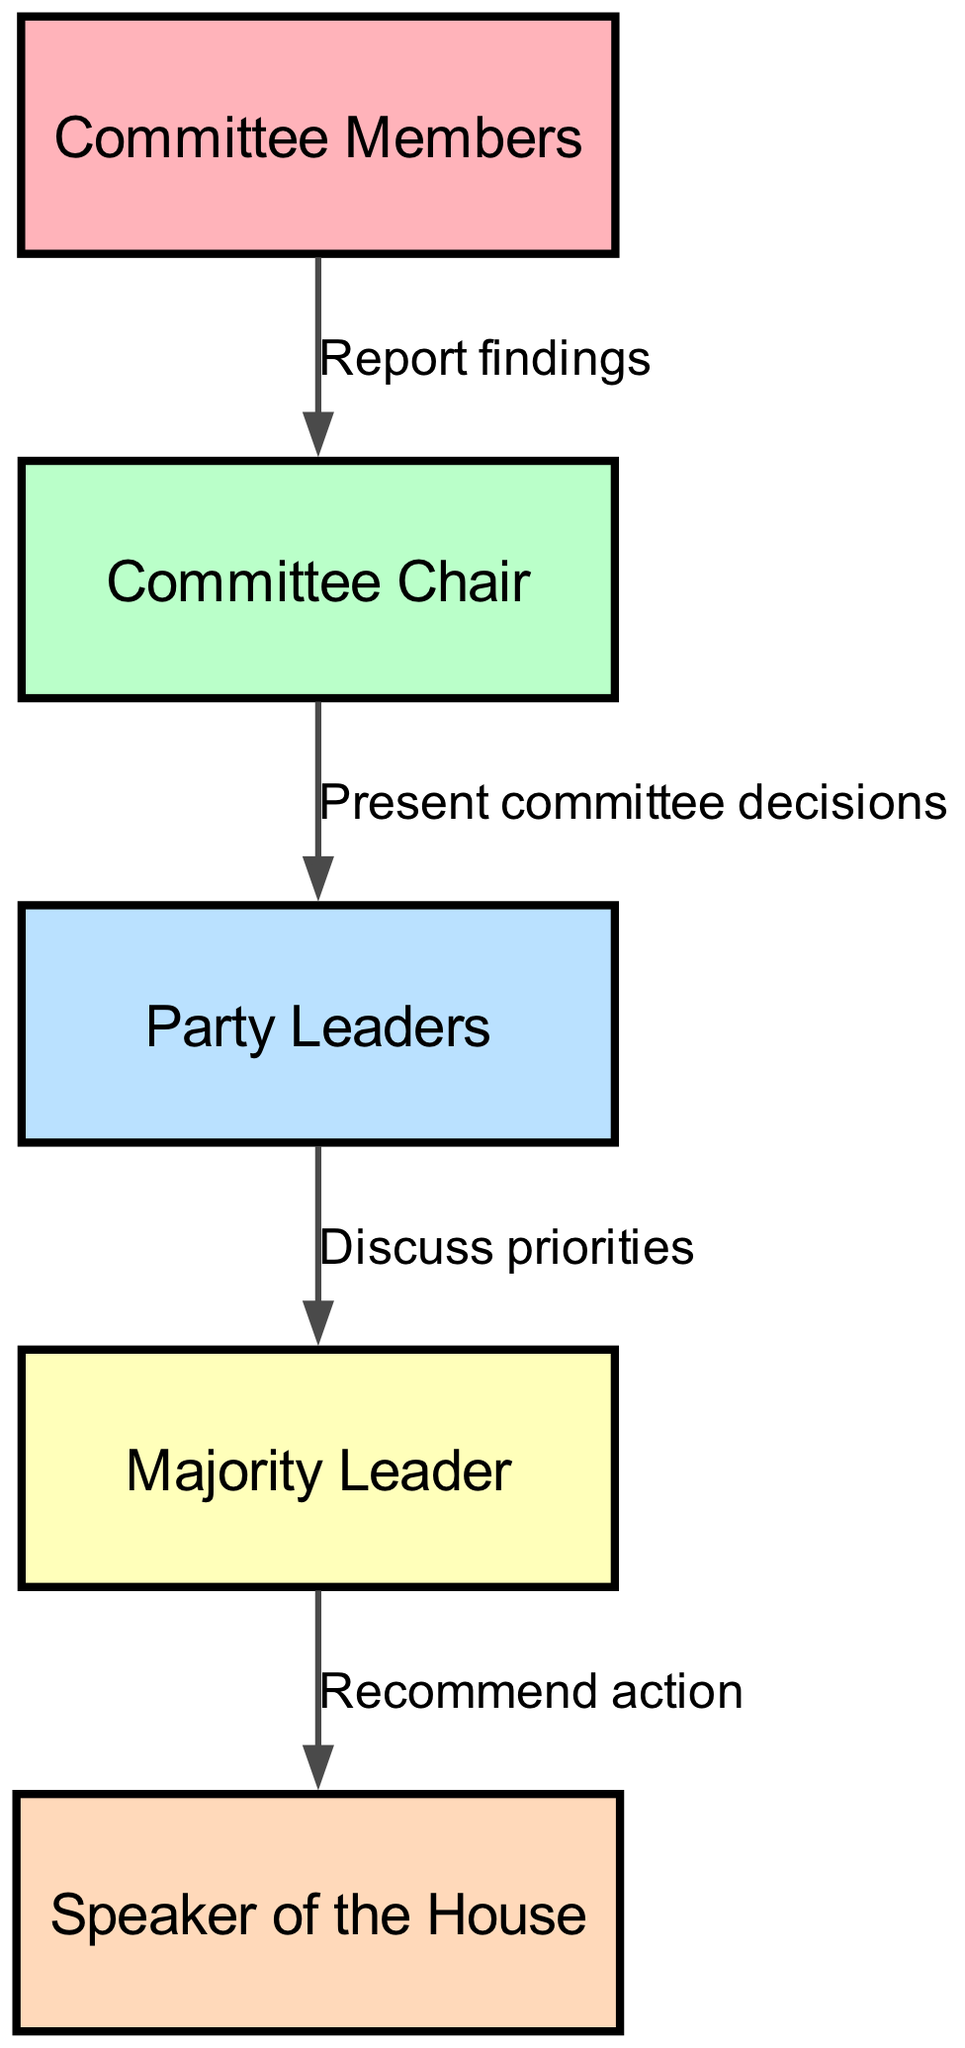What is the first node in the flow? The first node in the flow is "Committee Members," which is where the process begins.
Answer: Committee Members How many nodes are there in the diagram? By counting each distinct entity listed under "nodes," we find there are five nodes: Committee Members, Committee Chair, Party Leaders, Majority Leader, and Speaker of the House.
Answer: 5 What action do Committee Members take towards the Committee Chair? Committee Members report their findings to the Committee Chair, indicating a communication flow from the former to the latter.
Answer: Report findings Who do Party Leaders discuss priorities with? According to the edges, Party Leaders discuss priorities with the Majority Leader, showing a direct connection in the decision-making process.
Answer: Majority Leader What is the final recommendation made in the flow? The final recommendation made in the flow is by the Majority Leader to the Speaker of the House, identifying the culmination of the decision-making process.
Answer: Recommend action Which node receives the Committee Chair's presentations? The Committee Chair presents committee decisions to the Party Leaders, creating a pathway between these two nodes in the legislative flow.
Answer: Party Leaders What is the relationship between the Majority Leader and the Speaker of the House? The Majority Leader recommends action to the Speaker of the House, indicating a guiding function in the reporting structure.
Answer: Recommend action What colors are used for the nodes in the diagram? The colors used for the nodes include soft pastels like light red, green, blue, yellow, and orange, which are designated for easy differentiation among nodes.
Answer: Light red, green, blue, yellow, orange What is the overall direction of the flow in the diagram? The overall direction of the flow is top to bottom, illustrating a hierarchy and sequence of actions from Committee Members through to the Speaker of the House.
Answer: Top to bottom 